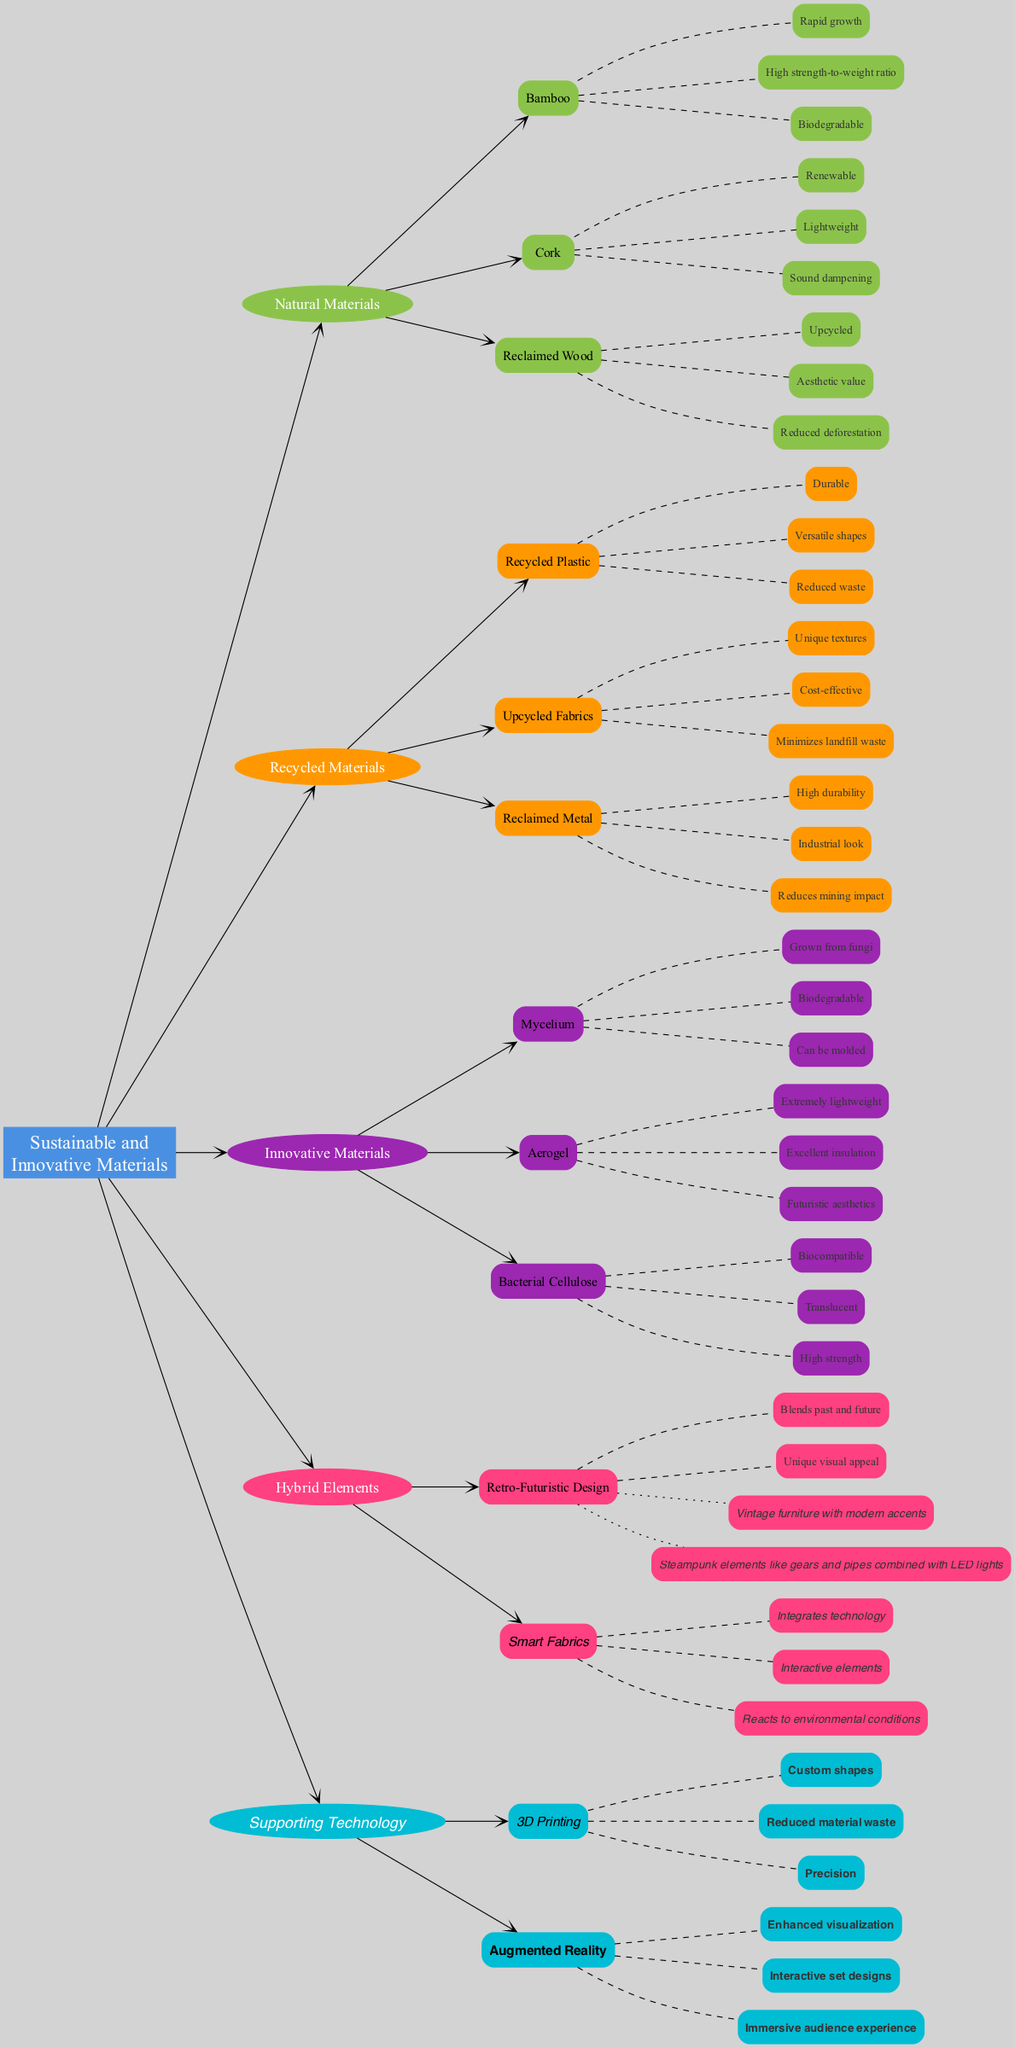What are the three categories of materials included in the diagram? The diagram lists three categories of materials: Natural Materials, Recycled Materials, and Innovative Materials. These categories are connected directly to the main node, defining the overall theme of sustainable and innovative materials.
Answer: Natural Materials, Recycled Materials, Innovative Materials How many examples are provided under the Hybrid Elements category? Within the Hybrid Elements category, there are two examples provided: "Vintage furniture with modern accents" and "Steampunk elements like gears and pipes combined with LED lights." This is determined by counting the examples listed under the respective node.
Answer: 2 What unique feature do Smart Fabrics have? Smart Fabrics are characterized by attributes that state they "Integrate technology" and "Interactive elements." To determine the unique feature, we look directly at the attributes assigned to this specific item in the diagram.
Answer: Integrates technology Which material is described as having an "Excellent insulation" property? The diagram indicates that Aerogel possesses "Excellent insulation" as one of its attributes. This requires checking the attributes listed under the Innovative Materials section and identifying the specific material that matches the description.
Answer: Aerogel What is the color used for Recycled Materials in the diagram? The color assigned to Recycled Materials is #FF9800. This can be determined by referencing the defined color scheme that associates specific colors with each category mentioned in the diagram.
Answer: #FF9800 List one attribute of Bacterial Cellulose. Bacterial Cellulose has the attribute "Biocompatible." To find this information, we look under the Innovative Materials and read the attributes listed under Bacterial Cellulose specifically.
Answer: Biocompatible How many benefits are listed under Supporting Technology? The Supporting Technology section includes two benefits: "Custom shapes" and "Reduced material waste." This entails counting the benefits as outlined under this category in the diagram.
Answer: 3 Which natural material is noted for its "Sound dampening" properties? Cork is identified in the diagram as having the attribute "Sound dampening." This involves locating the Natural Materials category and examining the attributes listed for Cork specifically.
Answer: Cork Which material is noted as being "Extremely lightweight"? The material recognized for being "Extremely lightweight" is Aerogel, found under the Innovative Materials category. This answer comes from checking the attributes listed for each item in the respective section.
Answer: Aerogel 